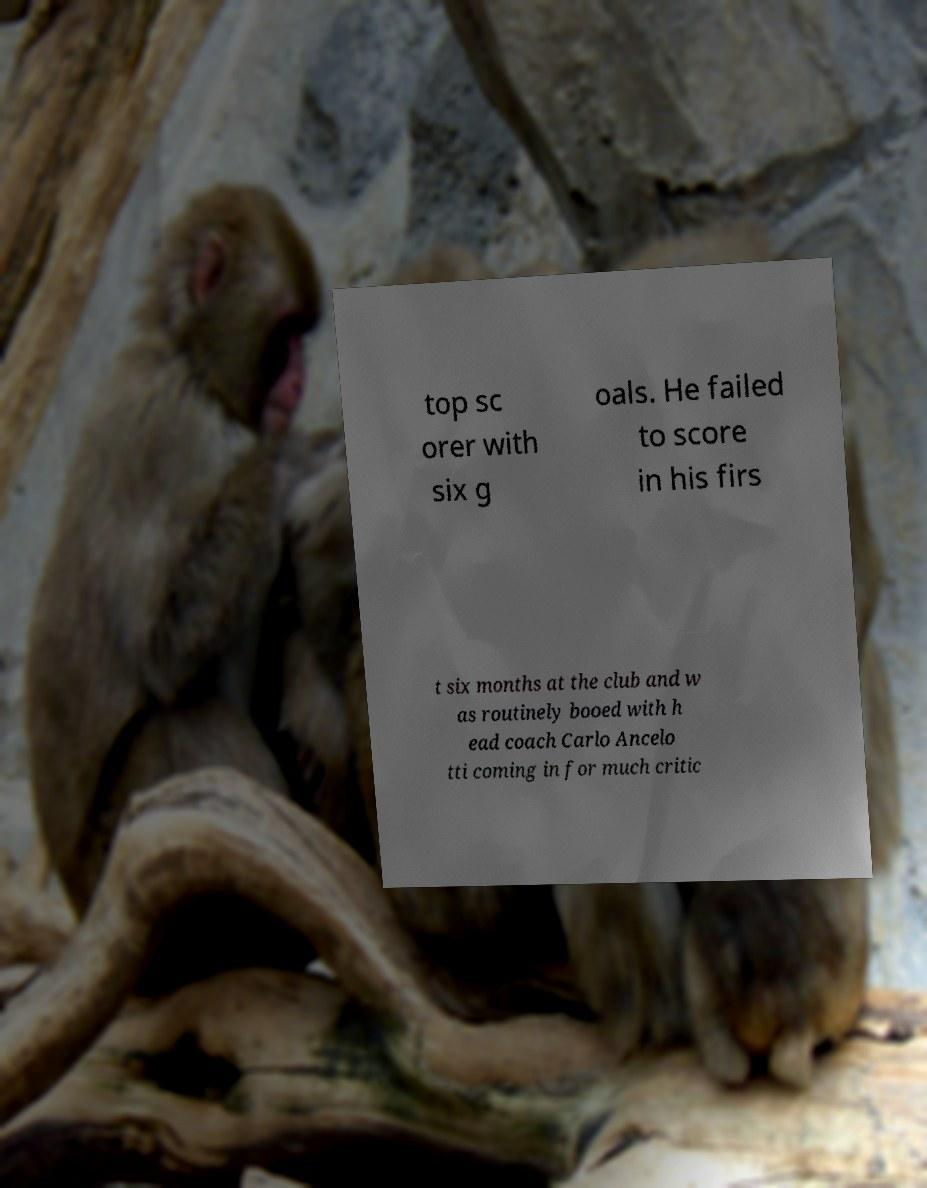I need the written content from this picture converted into text. Can you do that? top sc orer with six g oals. He failed to score in his firs t six months at the club and w as routinely booed with h ead coach Carlo Ancelo tti coming in for much critic 